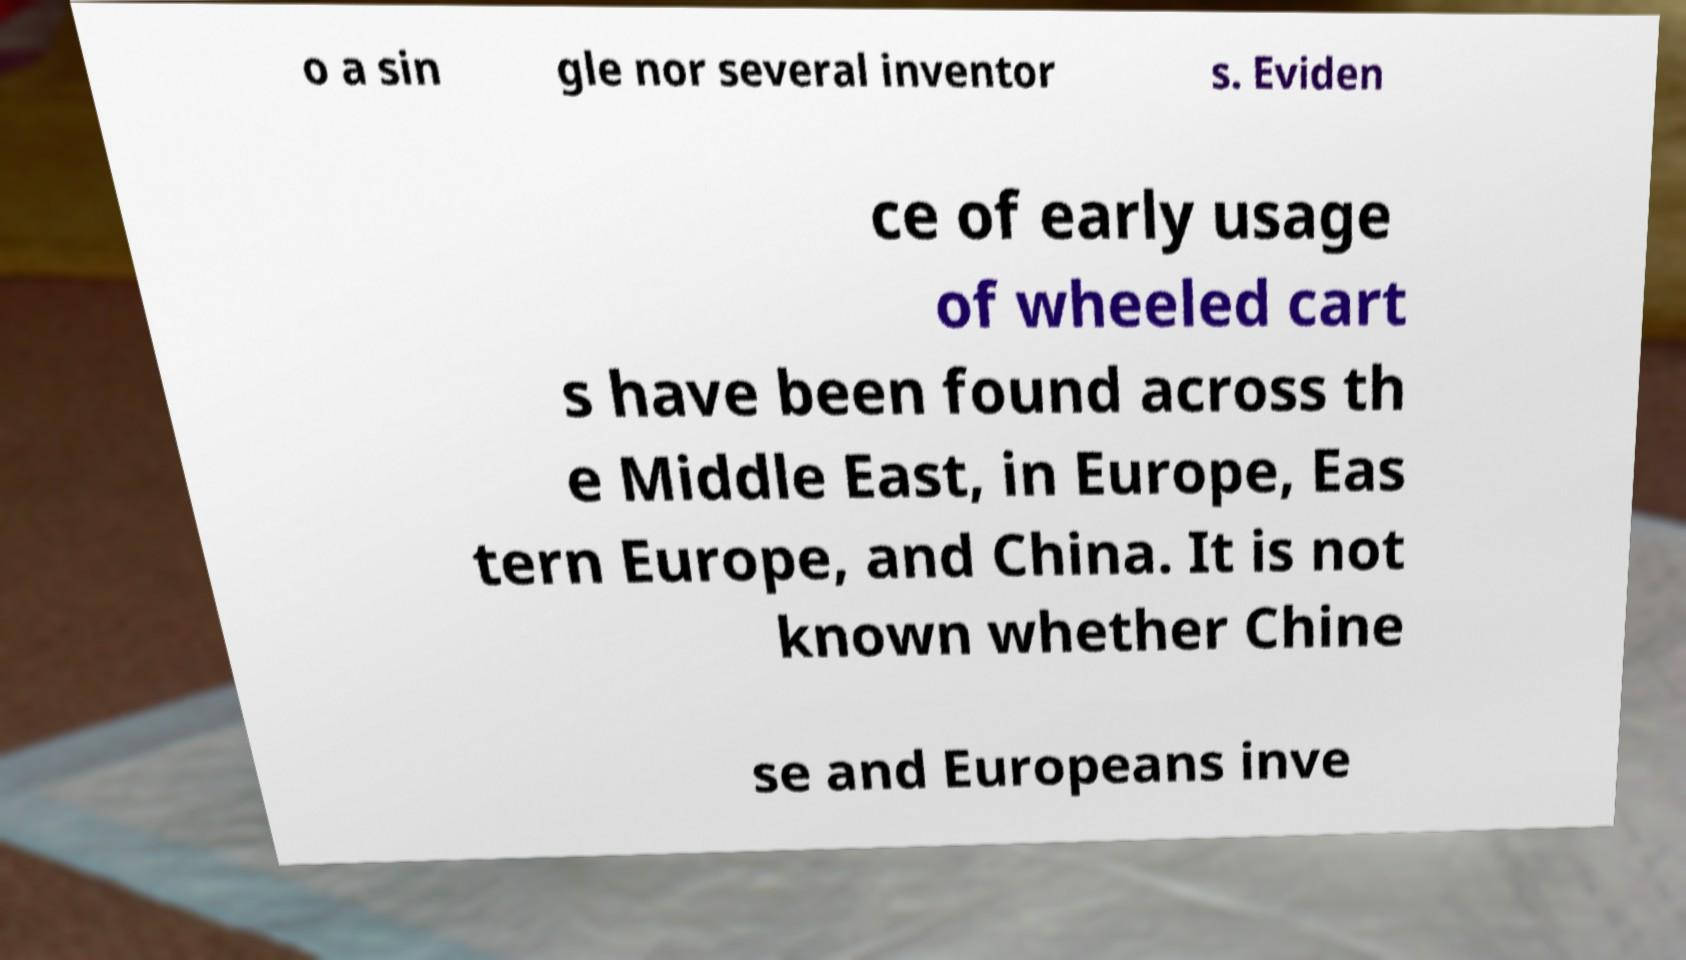Can you accurately transcribe the text from the provided image for me? o a sin gle nor several inventor s. Eviden ce of early usage of wheeled cart s have been found across th e Middle East, in Europe, Eas tern Europe, and China. It is not known whether Chine se and Europeans inve 